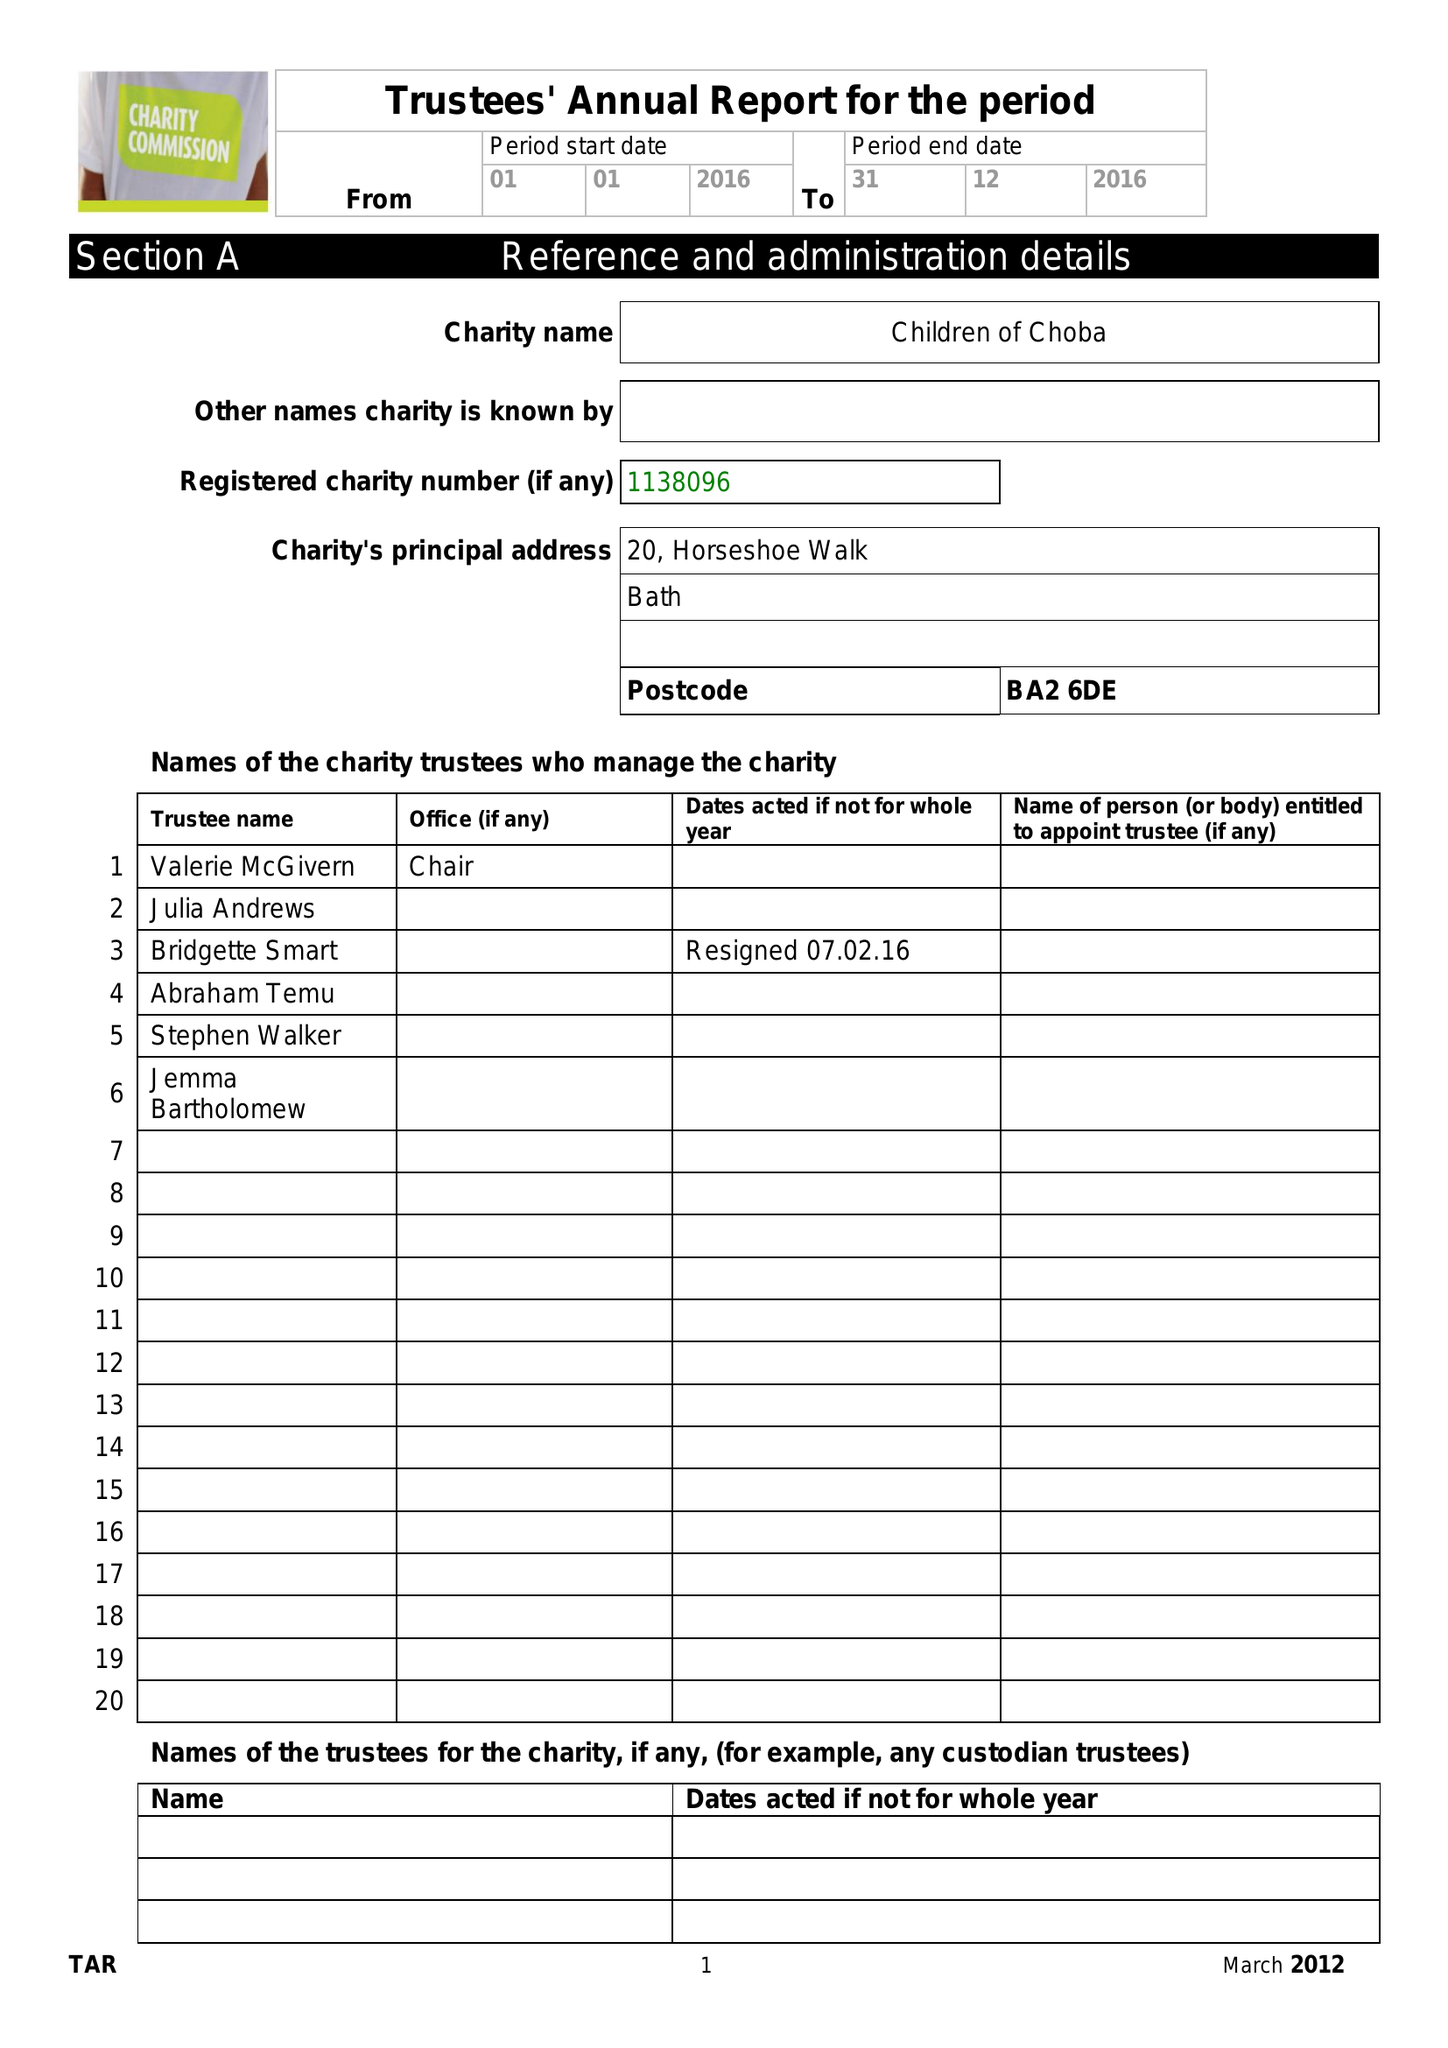What is the value for the report_date?
Answer the question using a single word or phrase. 2016-12-31 